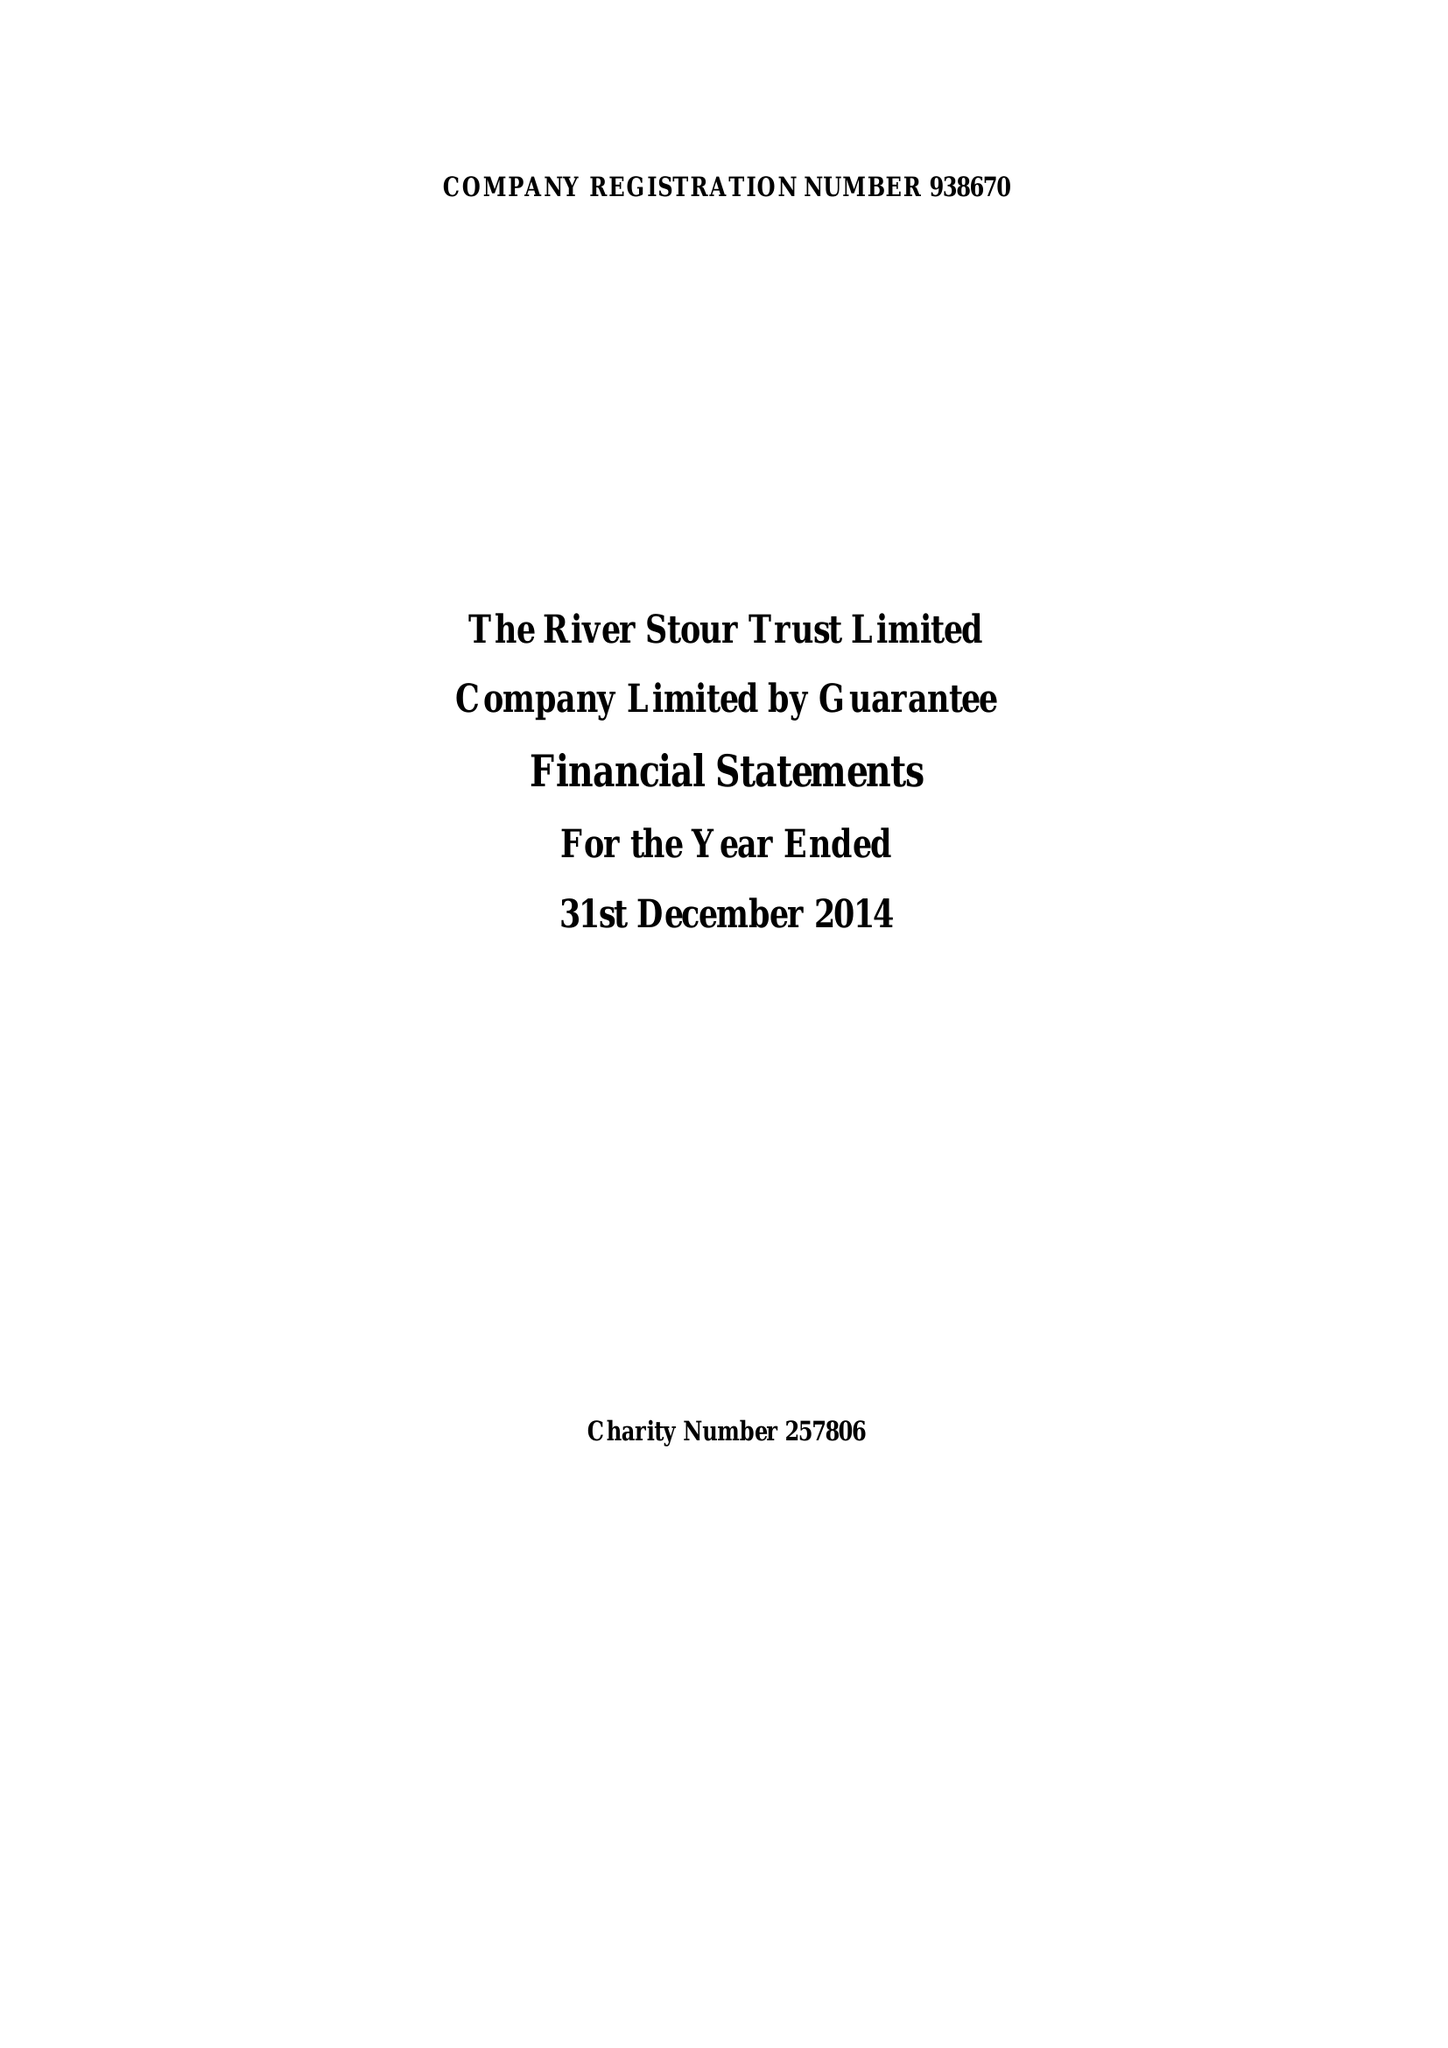What is the value for the address__postcode?
Answer the question using a single word or phrase. CO10 2AN 